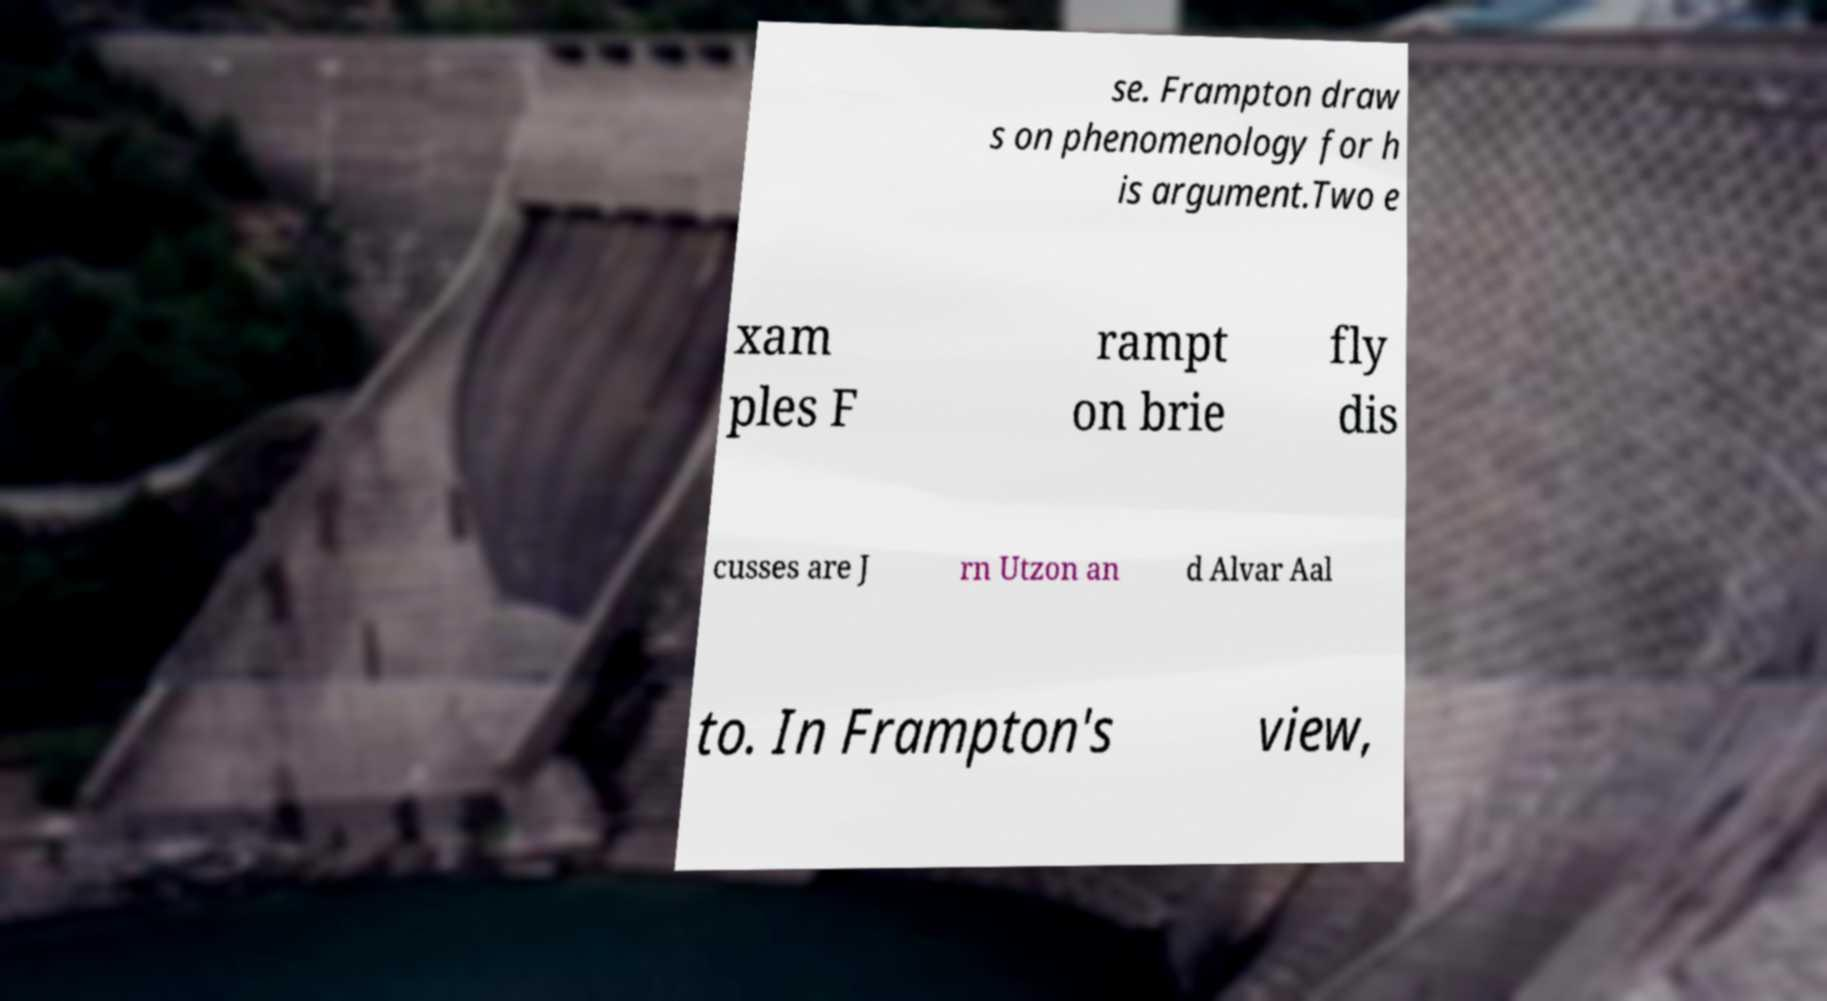Could you assist in decoding the text presented in this image and type it out clearly? se. Frampton draw s on phenomenology for h is argument.Two e xam ples F rampt on brie fly dis cusses are J rn Utzon an d Alvar Aal to. In Frampton's view, 